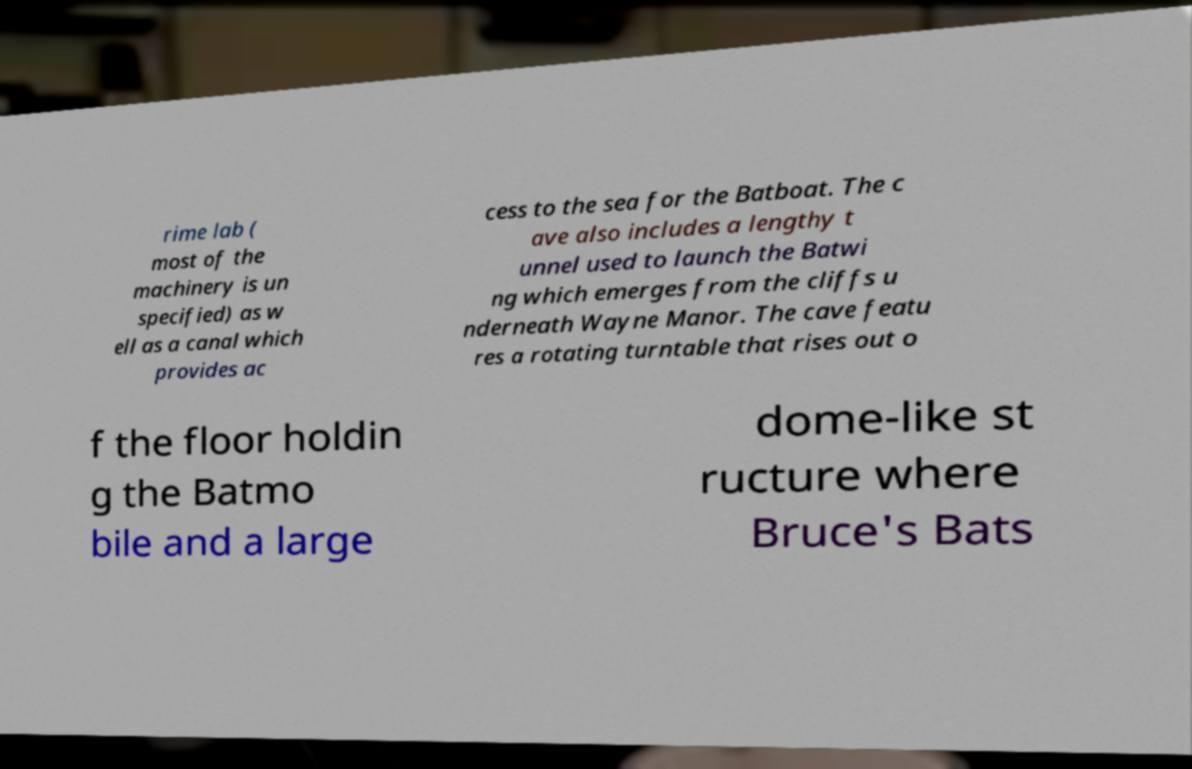Can you read and provide the text displayed in the image?This photo seems to have some interesting text. Can you extract and type it out for me? rime lab ( most of the machinery is un specified) as w ell as a canal which provides ac cess to the sea for the Batboat. The c ave also includes a lengthy t unnel used to launch the Batwi ng which emerges from the cliffs u nderneath Wayne Manor. The cave featu res a rotating turntable that rises out o f the floor holdin g the Batmo bile and a large dome-like st ructure where Bruce's Bats 